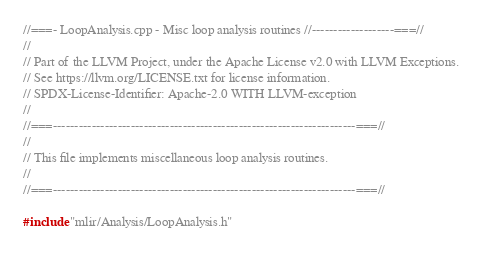<code> <loc_0><loc_0><loc_500><loc_500><_C++_>//===- LoopAnalysis.cpp - Misc loop analysis routines //-------------------===//
//
// Part of the LLVM Project, under the Apache License v2.0 with LLVM Exceptions.
// See https://llvm.org/LICENSE.txt for license information.
// SPDX-License-Identifier: Apache-2.0 WITH LLVM-exception
//
//===----------------------------------------------------------------------===//
//
// This file implements miscellaneous loop analysis routines.
//
//===----------------------------------------------------------------------===//

#include "mlir/Analysis/LoopAnalysis.h"
</code> 